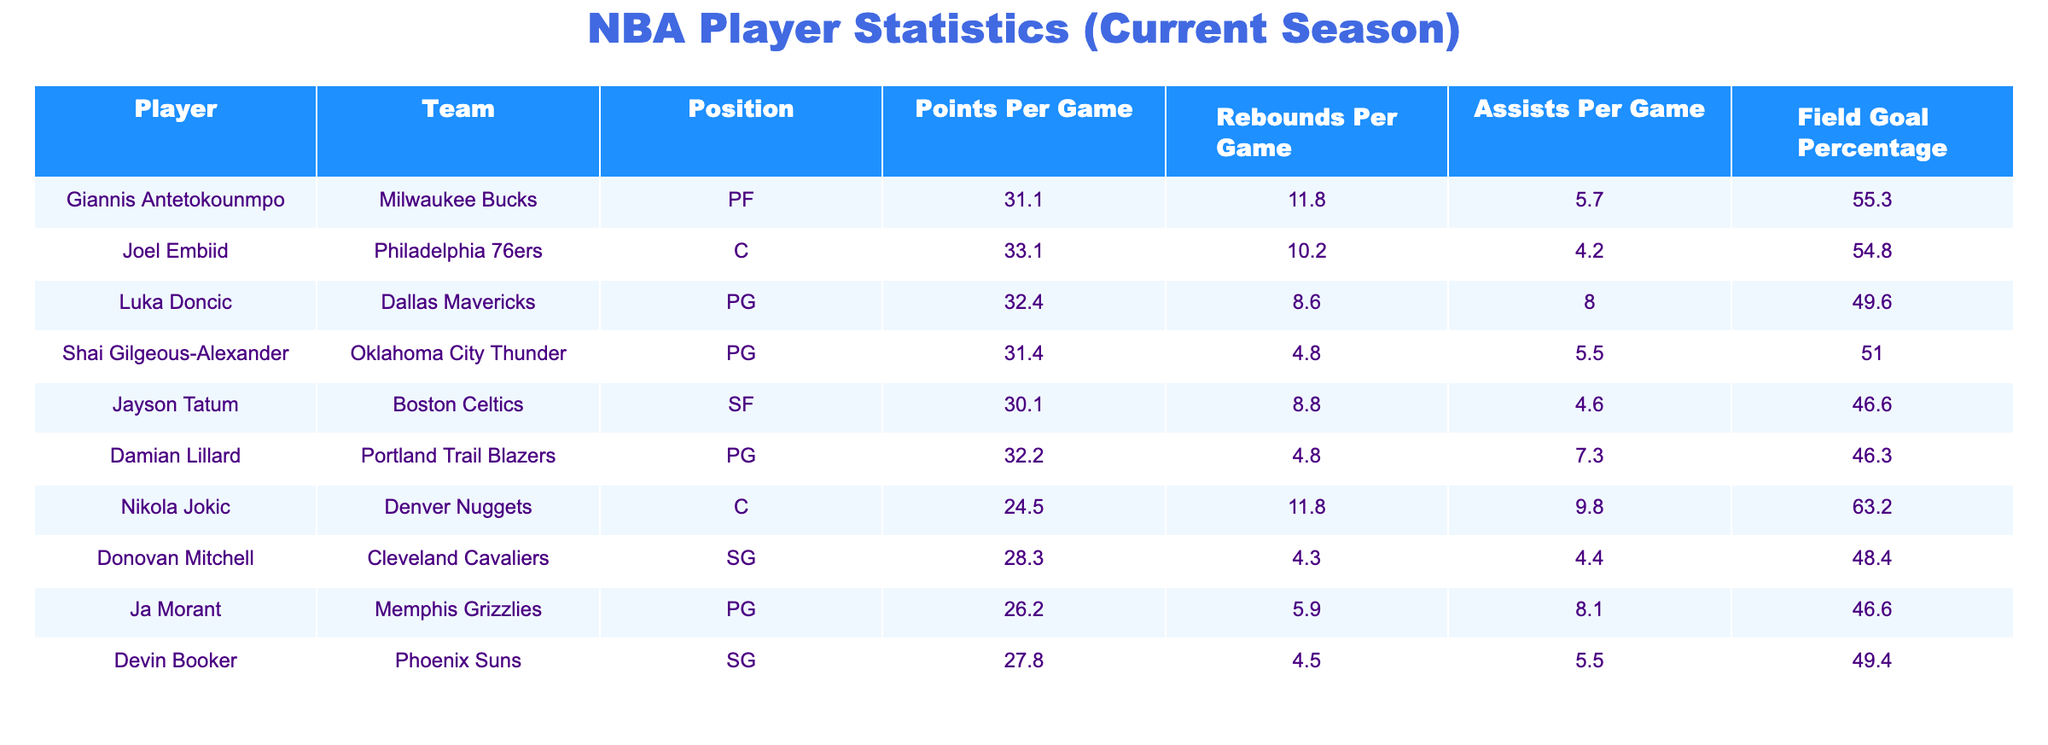What is the average Points Per Game for the players listed? To find the average Points Per Game, we need to sum the Points Per Game of all players: (31.1 + 33.1 + 32.4 + 31.4 + 30.1 + 32.2 + 24.5 + 28.3 + 26.2 + 27.8) =  296.1. Then we divide by the total number of players, which is 10: 296.1 / 10 = 29.61.
Answer: 29.61 Who has the highest Rebounds Per Game? By examining the Rebounds Per Game column, we can see that both Giannis Antetokounmpo and Nikola Jokic have 11.8 rebounds per game, which is the highest among the players listed.
Answer: Giannis Antetokounmpo and Nikola Jokic Is Joel Embiid leading in both Points and Rebounds per Game? Checking the table, Joel Embiid has 33.1 Points Per Game, which is the highest, but he has 10.2 Rebounds Per Game, while Giannis Antetokounmpo and Nikola Jokic each have 11.8. Thus, he does not lead in Rebounds.
Answer: No What is the difference in Points Per Game between Luka Doncic and Damian Lillard? Luka Doncic has 32.4 Points Per Game and Damian Lillard has 32.2. The difference is calculated by subtracting Lillard’s points from Doncic’s: 32.4 - 32.2 = 0.2.
Answer: 0.2 Which player has the highest Field Goal Percentage and what is that percentage? Looking at the Field Goal Percentage column, Nikola Jokic has the highest percentage at 63.2.
Answer: 63.2 Do more players have over 30 Points Per Game or under? Counting from the table, there are 5 players (Giannis, Joel, Luka, Shai, Damian) with over 30 Points Per Game and 5 players (Nikola, Donovan, Ja, Devin) with under 30. Therefore, the counts are equal.
Answer: Equal What is the total number of Assists Per Game for the players listed? To find the total Assists Per Game, we sum the values: (5.7 + 4.2 + 8.0 + 5.5 + 4.6 + 7.3 + 9.8 + 4.4 + 8.1 + 5.5) = 63.1.
Answer: 63.1 Is Damian Lillard's Field Goal Percentage higher than Shai Gilgeous-Alexander's? Damian Lillard has a Field Goal Percentage of 46.3, while Shai Gilgeous-Alexander has 51.0. Since 46.3 is less than 51.0, Lillard's percentage is not higher.
Answer: No Who has the lowest Points Per Game among the players listed? From the Points Per Game column, Nikola Jokic has the lowest value with 24.5.
Answer: Nikola Jokic 